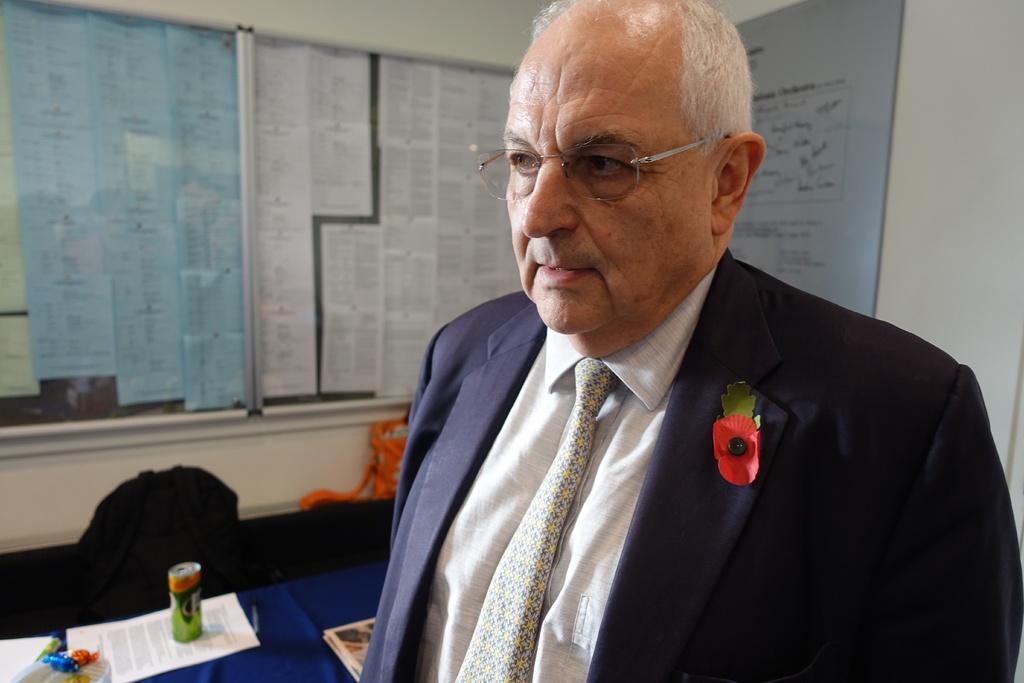In one or two sentences, can you explain what this image depicts? In this image I can see the person standing and the person is wearing blue blazer, cream color shirt and, cream and yellow color tie. Background I can see few papers on the table and I can also see few boards attached to the wall and the wall is in white color. 